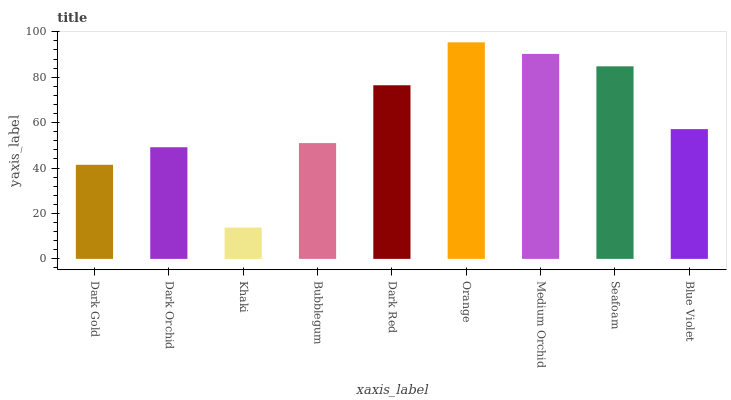Is Khaki the minimum?
Answer yes or no. Yes. Is Orange the maximum?
Answer yes or no. Yes. Is Dark Orchid the minimum?
Answer yes or no. No. Is Dark Orchid the maximum?
Answer yes or no. No. Is Dark Orchid greater than Dark Gold?
Answer yes or no. Yes. Is Dark Gold less than Dark Orchid?
Answer yes or no. Yes. Is Dark Gold greater than Dark Orchid?
Answer yes or no. No. Is Dark Orchid less than Dark Gold?
Answer yes or no. No. Is Blue Violet the high median?
Answer yes or no. Yes. Is Blue Violet the low median?
Answer yes or no. Yes. Is Dark Orchid the high median?
Answer yes or no. No. Is Seafoam the low median?
Answer yes or no. No. 